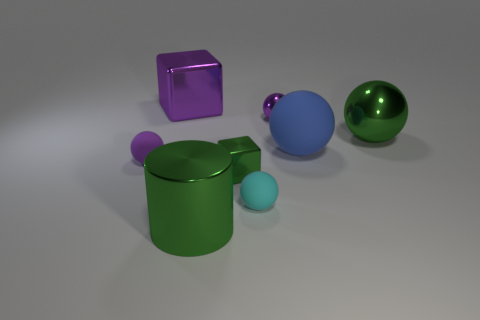Subtract all purple shiny balls. How many balls are left? 4 Add 1 small brown matte blocks. How many objects exist? 9 Subtract all green cubes. How many cubes are left? 1 Subtract all green cubes. How many purple balls are left? 2 Subtract 2 cubes. How many cubes are left? 0 Add 6 tiny purple matte balls. How many tiny purple matte balls exist? 7 Subtract 0 yellow cubes. How many objects are left? 8 Subtract all cubes. How many objects are left? 6 Subtract all green cubes. Subtract all cyan cylinders. How many cubes are left? 1 Subtract all small purple shiny spheres. Subtract all purple matte objects. How many objects are left? 6 